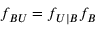Convert formula to latex. <formula><loc_0><loc_0><loc_500><loc_500>f _ { B U } = f _ { U | B } f _ { B }</formula> 